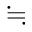Convert formula to latex. <formula><loc_0><loc_0><loc_500><loc_500>\ f a l l i n g d o t s e q</formula> 